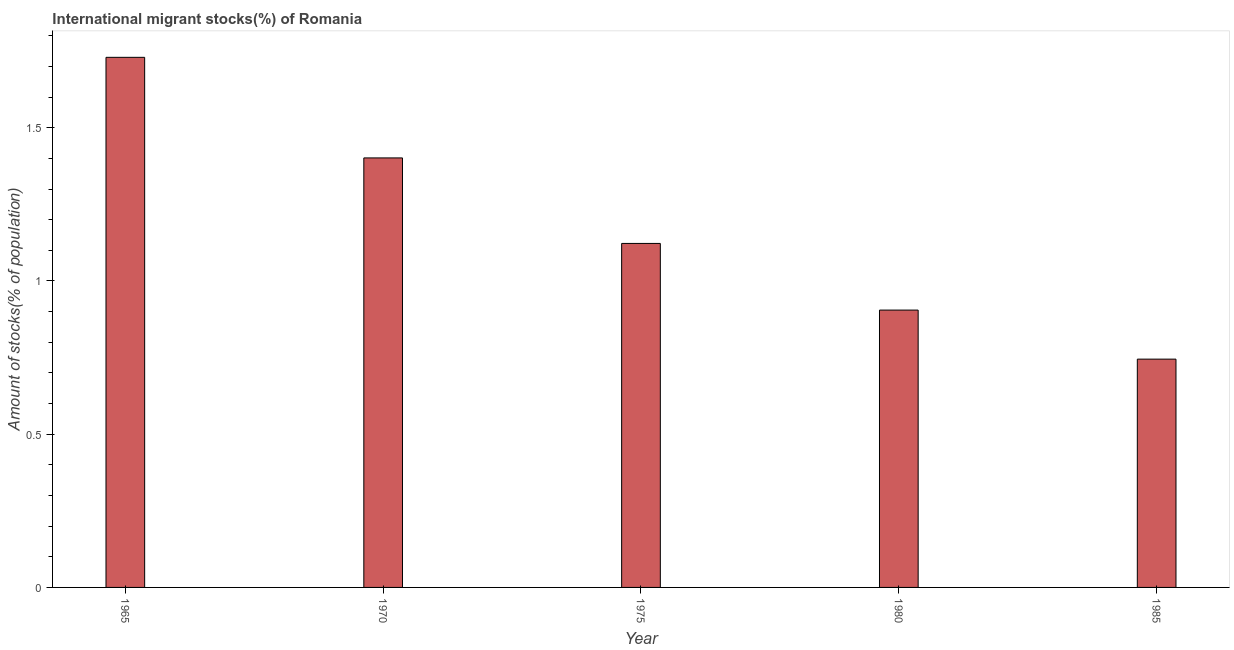What is the title of the graph?
Provide a succinct answer. International migrant stocks(%) of Romania. What is the label or title of the Y-axis?
Your response must be concise. Amount of stocks(% of population). What is the number of international migrant stocks in 1985?
Provide a succinct answer. 0.75. Across all years, what is the maximum number of international migrant stocks?
Keep it short and to the point. 1.73. Across all years, what is the minimum number of international migrant stocks?
Provide a short and direct response. 0.75. In which year was the number of international migrant stocks maximum?
Offer a terse response. 1965. What is the sum of the number of international migrant stocks?
Your answer should be very brief. 5.9. What is the difference between the number of international migrant stocks in 1975 and 1980?
Your answer should be compact. 0.22. What is the average number of international migrant stocks per year?
Your answer should be very brief. 1.18. What is the median number of international migrant stocks?
Your answer should be very brief. 1.12. What is the ratio of the number of international migrant stocks in 1970 to that in 1980?
Provide a short and direct response. 1.55. Is the number of international migrant stocks in 1965 less than that in 1970?
Provide a short and direct response. No. What is the difference between the highest and the second highest number of international migrant stocks?
Offer a terse response. 0.33. Are the values on the major ticks of Y-axis written in scientific E-notation?
Provide a short and direct response. No. What is the Amount of stocks(% of population) in 1965?
Your answer should be compact. 1.73. What is the Amount of stocks(% of population) in 1970?
Provide a succinct answer. 1.4. What is the Amount of stocks(% of population) in 1975?
Offer a terse response. 1.12. What is the Amount of stocks(% of population) in 1980?
Your response must be concise. 0.91. What is the Amount of stocks(% of population) in 1985?
Offer a terse response. 0.75. What is the difference between the Amount of stocks(% of population) in 1965 and 1970?
Provide a succinct answer. 0.33. What is the difference between the Amount of stocks(% of population) in 1965 and 1975?
Offer a very short reply. 0.61. What is the difference between the Amount of stocks(% of population) in 1965 and 1980?
Provide a succinct answer. 0.82. What is the difference between the Amount of stocks(% of population) in 1965 and 1985?
Keep it short and to the point. 0.98. What is the difference between the Amount of stocks(% of population) in 1970 and 1975?
Keep it short and to the point. 0.28. What is the difference between the Amount of stocks(% of population) in 1970 and 1980?
Keep it short and to the point. 0.5. What is the difference between the Amount of stocks(% of population) in 1970 and 1985?
Your answer should be very brief. 0.66. What is the difference between the Amount of stocks(% of population) in 1975 and 1980?
Your answer should be compact. 0.22. What is the difference between the Amount of stocks(% of population) in 1975 and 1985?
Provide a short and direct response. 0.38. What is the difference between the Amount of stocks(% of population) in 1980 and 1985?
Offer a very short reply. 0.16. What is the ratio of the Amount of stocks(% of population) in 1965 to that in 1970?
Make the answer very short. 1.23. What is the ratio of the Amount of stocks(% of population) in 1965 to that in 1975?
Give a very brief answer. 1.54. What is the ratio of the Amount of stocks(% of population) in 1965 to that in 1980?
Ensure brevity in your answer.  1.91. What is the ratio of the Amount of stocks(% of population) in 1965 to that in 1985?
Make the answer very short. 2.32. What is the ratio of the Amount of stocks(% of population) in 1970 to that in 1975?
Provide a succinct answer. 1.25. What is the ratio of the Amount of stocks(% of population) in 1970 to that in 1980?
Offer a terse response. 1.55. What is the ratio of the Amount of stocks(% of population) in 1970 to that in 1985?
Provide a succinct answer. 1.88. What is the ratio of the Amount of stocks(% of population) in 1975 to that in 1980?
Ensure brevity in your answer.  1.24. What is the ratio of the Amount of stocks(% of population) in 1975 to that in 1985?
Keep it short and to the point. 1.51. What is the ratio of the Amount of stocks(% of population) in 1980 to that in 1985?
Give a very brief answer. 1.22. 